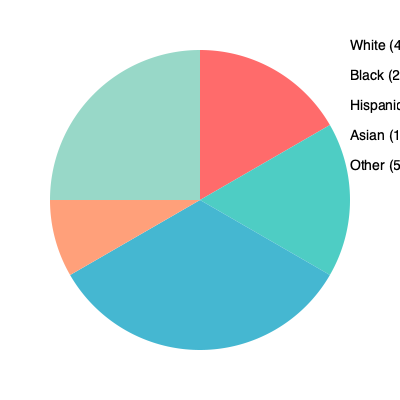Based on the pie chart showing college enrollment demographics, what percentage of students would be considered underrepresented minorities (Black, Hispanic, and Other combined)? To determine the percentage of underrepresented minorities, we need to follow these steps:

1. Identify the underrepresented minority groups in the chart:
   - Black: 25%
   - Hispanic: 20%
   - Other: 5%

2. Add up the percentages for these groups:
   $25\% + 20\% + 5\% = 50\%$

3. Verify the calculation:
   - White: 40%
   - Asian: 10%
   - Underrepresented minorities: 50%
   
   $40\% + 10\% + 50\% = 100\%$

Therefore, the percentage of students considered underrepresented minorities (Black, Hispanic, and Other combined) is 50%.
Answer: 50% 